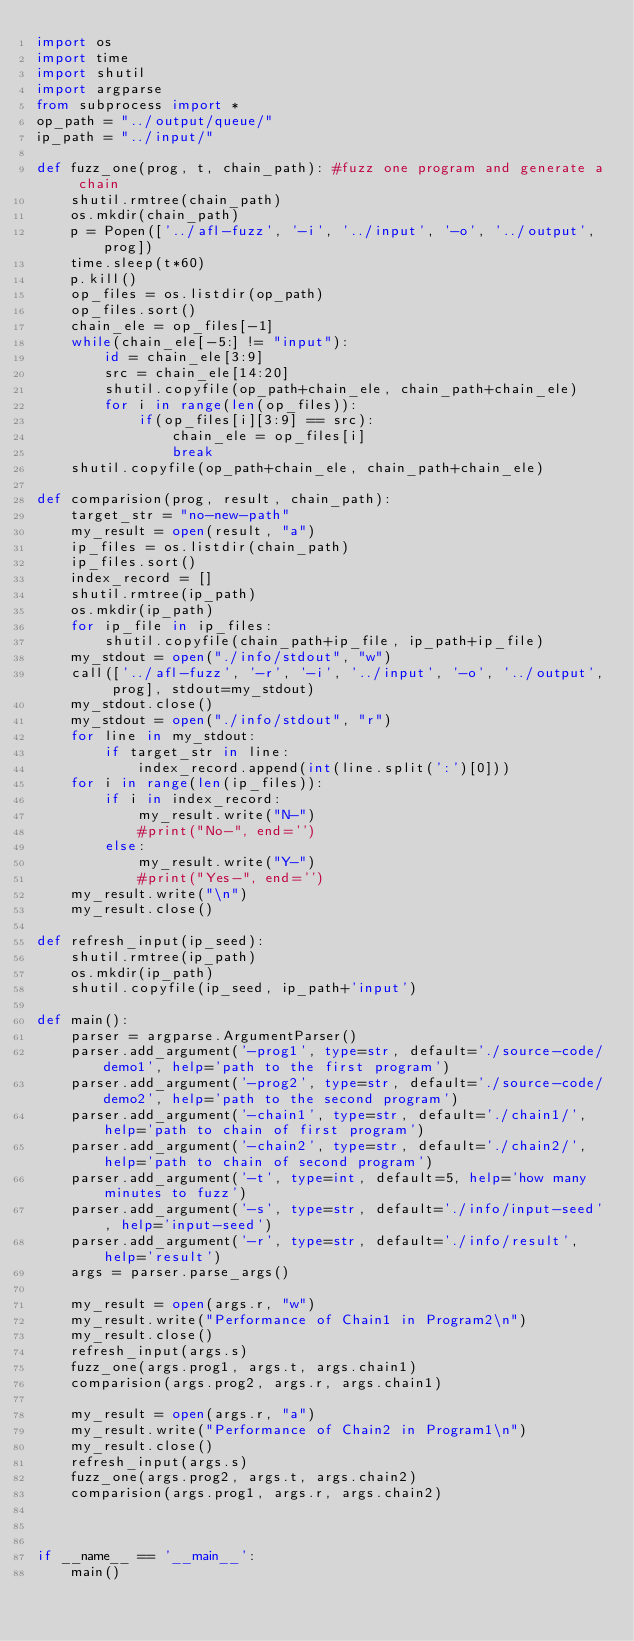<code> <loc_0><loc_0><loc_500><loc_500><_Python_>import os
import time
import shutil
import argparse
from subprocess import *
op_path = "../output/queue/"
ip_path = "../input/"

def fuzz_one(prog, t, chain_path): #fuzz one program and generate a chain
    shutil.rmtree(chain_path)
    os.mkdir(chain_path)
    p = Popen(['../afl-fuzz', '-i', '../input', '-o', '../output', prog])
    time.sleep(t*60)
    p.kill()
    op_files = os.listdir(op_path)
    op_files.sort()
    chain_ele = op_files[-1]
    while(chain_ele[-5:] != "input"):
        id = chain_ele[3:9]
        src = chain_ele[14:20]
        shutil.copyfile(op_path+chain_ele, chain_path+chain_ele)
        for i in range(len(op_files)):
            if(op_files[i][3:9] == src):
                chain_ele = op_files[i]
                break
    shutil.copyfile(op_path+chain_ele, chain_path+chain_ele)

def comparision(prog, result, chain_path):
    target_str = "no-new-path"
    my_result = open(result, "a")
    ip_files = os.listdir(chain_path)
    ip_files.sort()
    index_record = []
    shutil.rmtree(ip_path)
    os.mkdir(ip_path)
    for ip_file in ip_files:
        shutil.copyfile(chain_path+ip_file, ip_path+ip_file)
    my_stdout = open("./info/stdout", "w")
    call(['../afl-fuzz', '-r', '-i', '../input', '-o', '../output', prog], stdout=my_stdout)
    my_stdout.close()
    my_stdout = open("./info/stdout", "r")
    for line in my_stdout:
        if target_str in line:
            index_record.append(int(line.split(':')[0]))
    for i in range(len(ip_files)):
        if i in index_record:
            my_result.write("N-")
            #print("No-", end='')
        else:
            my_result.write("Y-")
            #print("Yes-", end='')
    my_result.write("\n")
    my_result.close()

def refresh_input(ip_seed):
    shutil.rmtree(ip_path)
    os.mkdir(ip_path)
    shutil.copyfile(ip_seed, ip_path+'input')

def main():
    parser = argparse.ArgumentParser()
    parser.add_argument('-prog1', type=str, default='./source-code/demo1', help='path to the first program')
    parser.add_argument('-prog2', type=str, default='./source-code/demo2', help='path to the second program')
    parser.add_argument('-chain1', type=str, default='./chain1/', help='path to chain of first program')
    parser.add_argument('-chain2', type=str, default='./chain2/', help='path to chain of second program')
    parser.add_argument('-t', type=int, default=5, help='how many minutes to fuzz')
    parser.add_argument('-s', type=str, default='./info/input-seed', help='input-seed')
    parser.add_argument('-r', type=str, default='./info/result', help='result')
    args = parser.parse_args()

    my_result = open(args.r, "w")
    my_result.write("Performance of Chain1 in Program2\n")
    my_result.close()
    refresh_input(args.s)
    fuzz_one(args.prog1, args.t, args.chain1)
    comparision(args.prog2, args.r, args.chain1)

    my_result = open(args.r, "a")
    my_result.write("Performance of Chain2 in Program1\n")
    my_result.close()
    refresh_input(args.s)
    fuzz_one(args.prog2, args.t, args.chain2)
    comparision(args.prog1, args.r, args.chain2)
    


if __name__ == '__main__':
    main()
</code> 